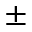<formula> <loc_0><loc_0><loc_500><loc_500>\pm</formula> 